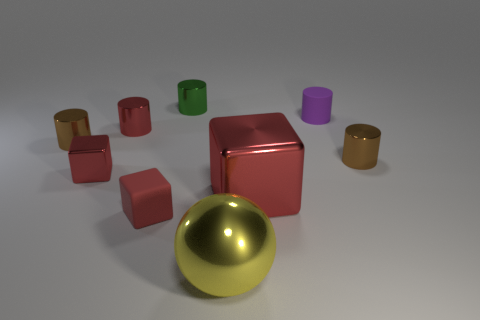Are there more tiny red cubes behind the big red cube than purple metallic cubes?
Offer a terse response. Yes. What is the material of the large block?
Your answer should be very brief. Metal. How many metal cubes have the same size as the purple rubber cylinder?
Your answer should be very brief. 1. Are there the same number of small brown metal objects that are in front of the green cylinder and big blocks that are behind the tiny red cylinder?
Provide a succinct answer. No. Does the large yellow ball have the same material as the large red cube?
Your answer should be very brief. Yes. There is a green metal object left of the large yellow sphere; are there any big red things to the left of it?
Keep it short and to the point. No. Are there any tiny green objects of the same shape as the large red shiny object?
Provide a succinct answer. No. Is the color of the big ball the same as the matte block?
Provide a succinct answer. No. What is the material of the red cylinder to the right of the brown shiny cylinder left of the tiny red matte object?
Provide a short and direct response. Metal. The rubber cylinder has what size?
Make the answer very short. Small. 